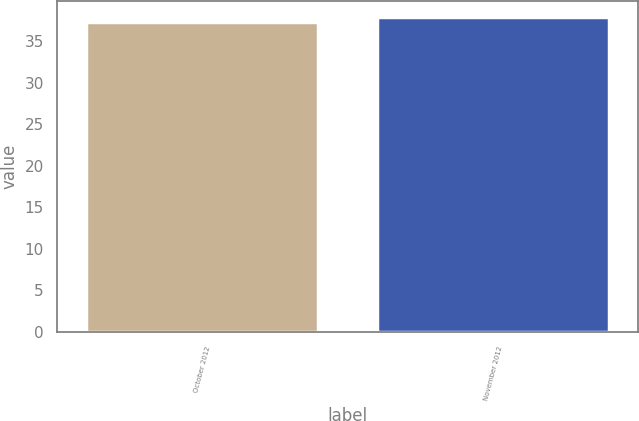Convert chart to OTSL. <chart><loc_0><loc_0><loc_500><loc_500><bar_chart><fcel>October 2012<fcel>November 2012<nl><fcel>37.27<fcel>37.95<nl></chart> 